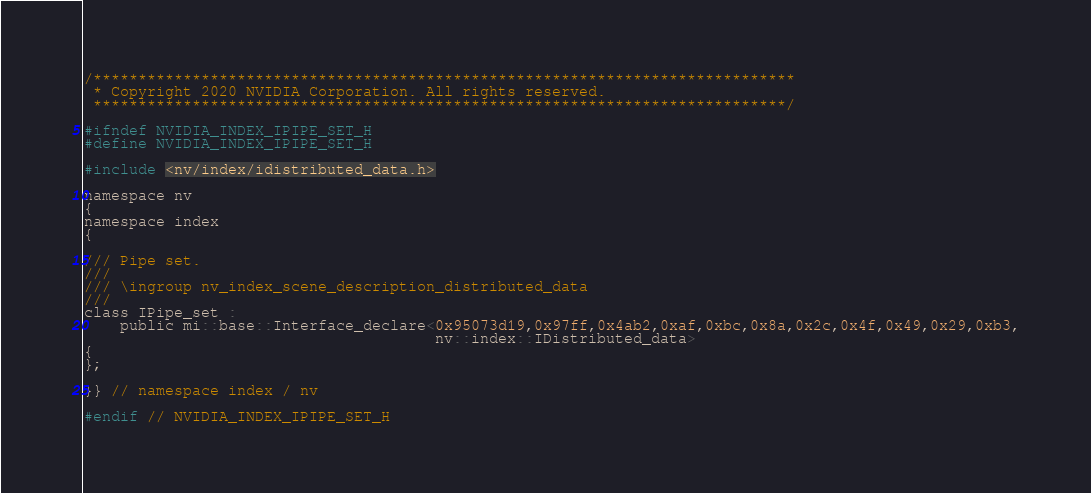<code> <loc_0><loc_0><loc_500><loc_500><_C_>/******************************************************************************
 * Copyright 2020 NVIDIA Corporation. All rights reserved.
 *****************************************************************************/

#ifndef NVIDIA_INDEX_IPIPE_SET_H
#define NVIDIA_INDEX_IPIPE_SET_H

#include <nv/index/idistributed_data.h>

namespace nv
{
namespace index
{

/// Pipe set.
///
/// \ingroup nv_index_scene_description_distributed_data
///
class IPipe_set :
    public mi::base::Interface_declare<0x95073d19,0x97ff,0x4ab2,0xaf,0xbc,0x8a,0x2c,0x4f,0x49,0x29,0xb3,
                                       nv::index::IDistributed_data>
{
};

}} // namespace index / nv

#endif // NVIDIA_INDEX_IPIPE_SET_H
</code> 